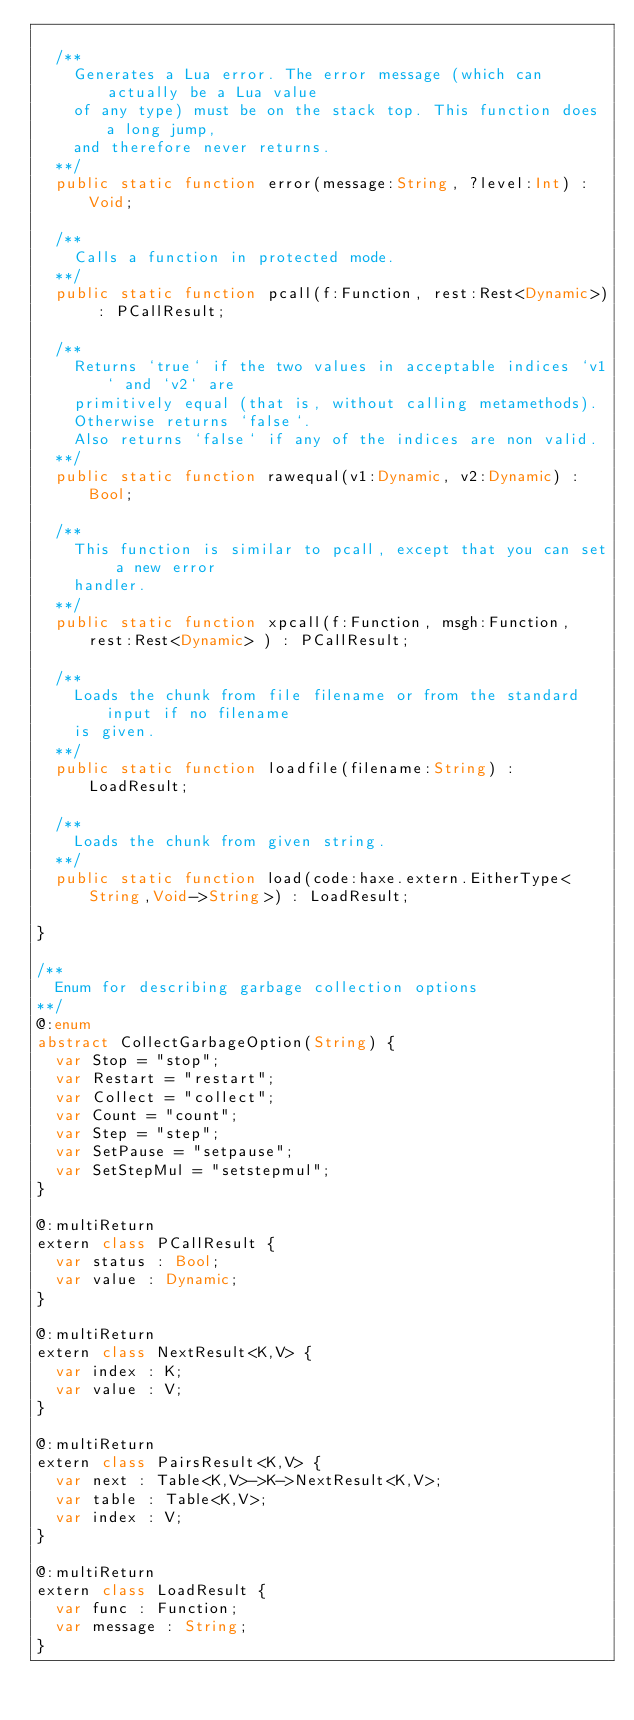<code> <loc_0><loc_0><loc_500><loc_500><_Haxe_>
	/**
		Generates a Lua error. The error message (which can actually be a Lua value
		of any type) must be on the stack top. This function does a long jump,
		and therefore never returns.
	**/
	public static function error(message:String, ?level:Int) : Void;

	/**
		Calls a function in protected mode.
	**/
	public static function pcall(f:Function, rest:Rest<Dynamic>) : PCallResult;

	/**
		Returns `true` if the two values in acceptable indices `v1` and `v2` are
		primitively equal (that is, without calling metamethods).
		Otherwise returns `false`.
		Also returns `false` if any of the indices are non valid.
	**/
	public static function rawequal(v1:Dynamic, v2:Dynamic) : Bool;

	/**
		This function is similar to pcall, except that you can set a new error
		handler.
	**/
	public static function xpcall(f:Function, msgh:Function, rest:Rest<Dynamic> ) : PCallResult;

	/**
		Loads the chunk from file filename or from the standard input if no filename
		is given.
	**/
	public static function loadfile(filename:String) : LoadResult;

	/**
		Loads the chunk from given string.
	**/
	public static function load(code:haxe.extern.EitherType<String,Void->String>) : LoadResult;

}

/**
	Enum for describing garbage collection options
**/
@:enum
abstract CollectGarbageOption(String) {
	var Stop = "stop";
	var Restart = "restart";
	var Collect = "collect";
	var Count = "count";
	var Step = "step";
	var SetPause = "setpause";
	var SetStepMul = "setstepmul";
}

@:multiReturn
extern class PCallResult {
	var status : Bool;
	var value : Dynamic;
}

@:multiReturn
extern class NextResult<K,V> {
	var index : K;
	var value : V;
}

@:multiReturn
extern class PairsResult<K,V> {
	var next : Table<K,V>->K->NextResult<K,V>;
	var table : Table<K,V>;
	var index : V;
}

@:multiReturn
extern class LoadResult {
	var func : Function;
	var message : String;
}
</code> 